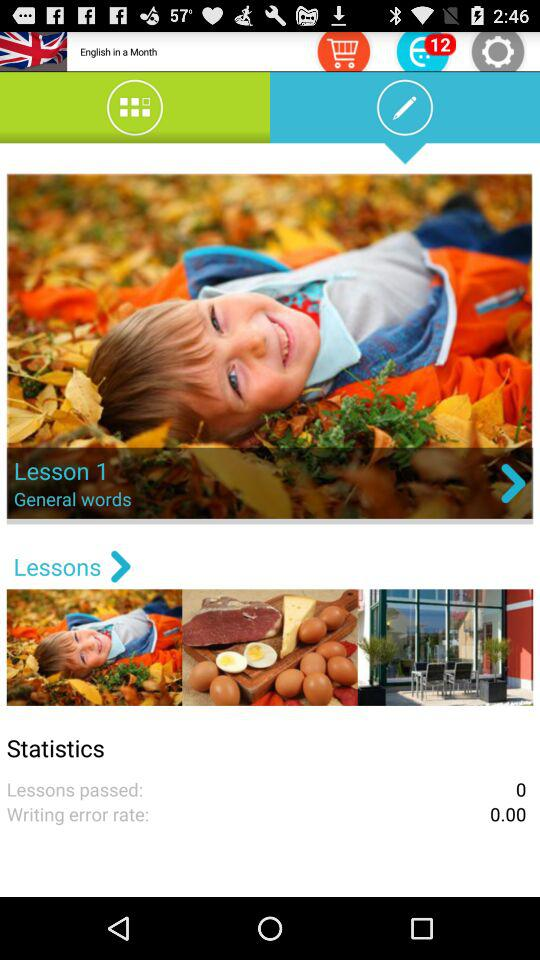What is the writing error rate? The writing error rate is 0. 